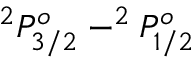<formula> <loc_0><loc_0><loc_500><loc_500>^ { 2 } P _ { 3 / 2 } ^ { o } - ^ { 2 } P _ { 1 / 2 } ^ { o }</formula> 